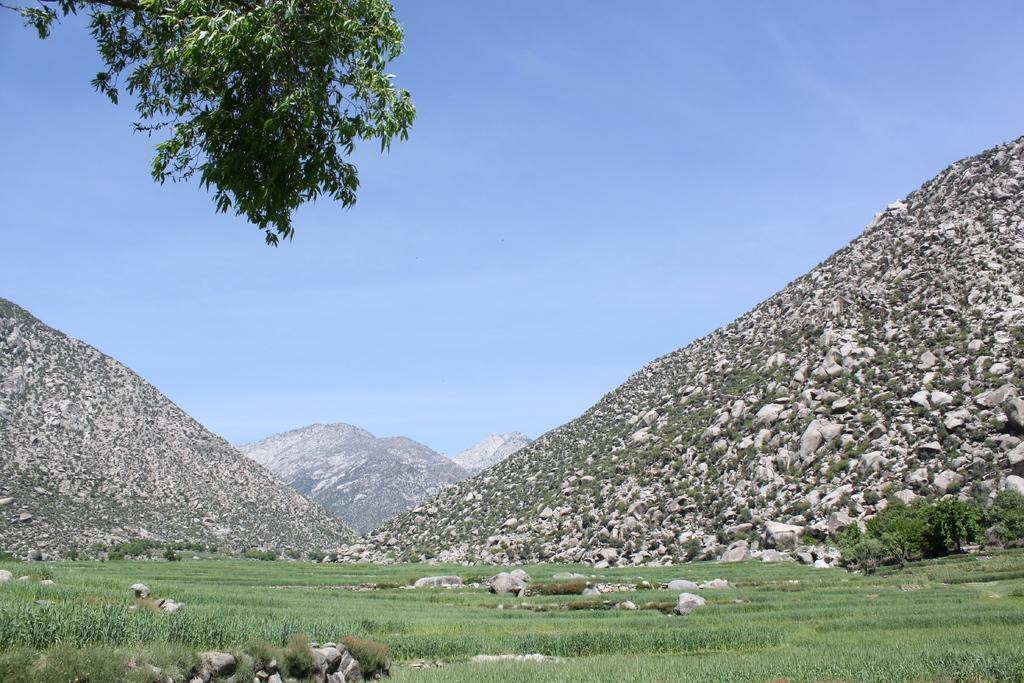What type of natural elements can be seen in the image? There are stones, mountains, and trees with green color in the image. What is the color of the sky in the image? The sky is blue and white in color. What type of connection can be seen between the stones and the trees in the image? There is no specific connection between the stones and the trees mentioned in the image. The image simply shows stones, mountains, trees, and the sky. 